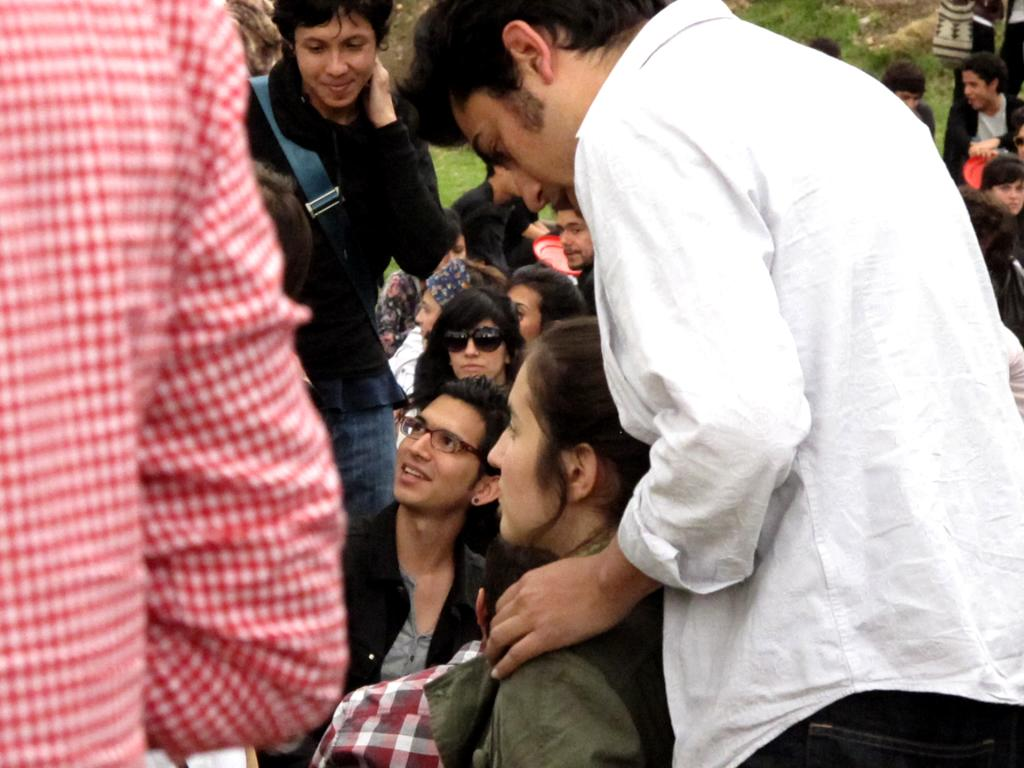How many people are in the image? There are people in the image, but the exact number is not specified. What is the woman wearing that is black in color? The woman is wearing black color shades. What color are the things that are mentioned in the image? There are red color things in the image. What type of activity is the mist involved in within the image? There is no mist present in the image, so it cannot be involved in any activity. 